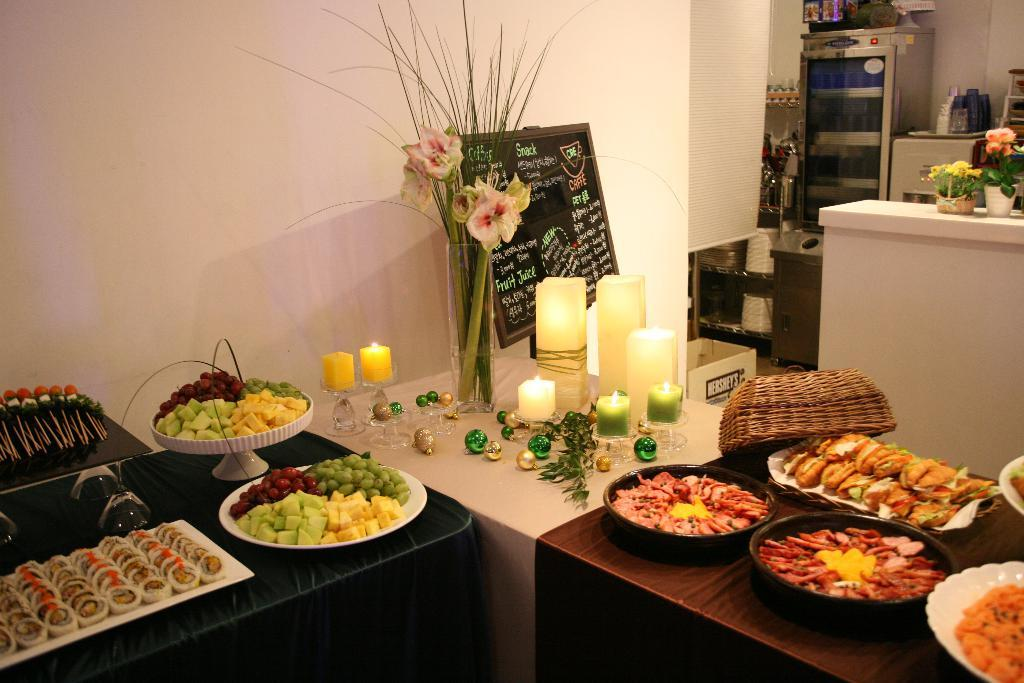What is on the plates that are visible in the image? There is food served on plates in the image. Where are the plates located? The plates are on a table. What can be seen in the middle of the table? There is a candle in the middle of the table. What other decorative item is present on the table? A flower-vase is present on the table. What appliance can be seen in the room? There is a fridge in the room. How does the anger in the room affect the garden outside? There is no mention of anger in the image, and the image does not show a garden outside. 